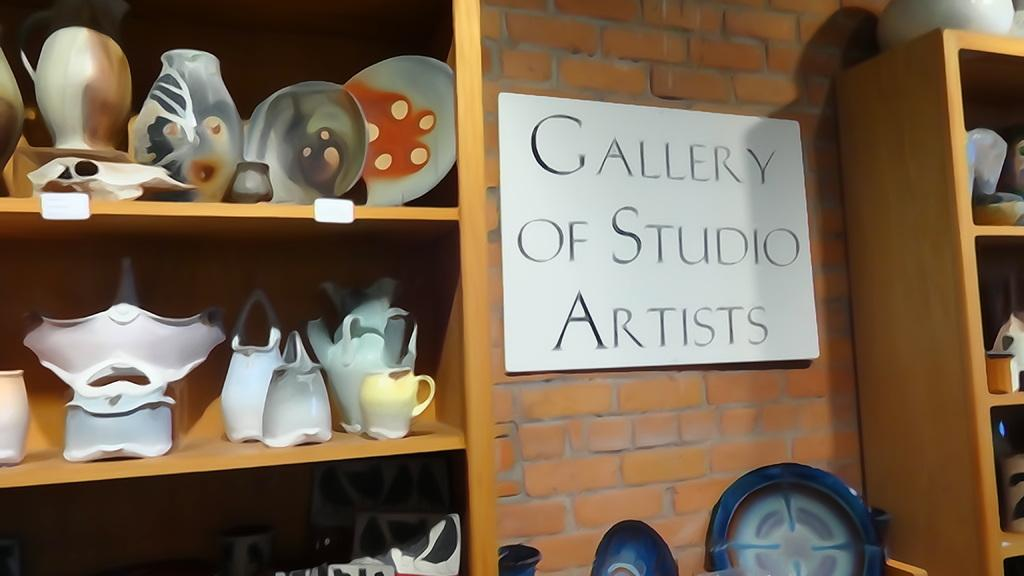What type of containers are on the wooden shelf in the image? There are ceramic jars on a wooden shelf on the left side of the image. What can be seen on the wall in the image? There is a billboard on a wall in the image. What is located on the right side of the image? There is another wooden drawer on the right side of the image. How many wings can be seen on the ceramic jars in the image? There are no wings present on the ceramic jars in the image. What type of crate is visible on the wooden shelf in the image? There is no crate visible on the wooden shelf in the image; only ceramic jars are present. 